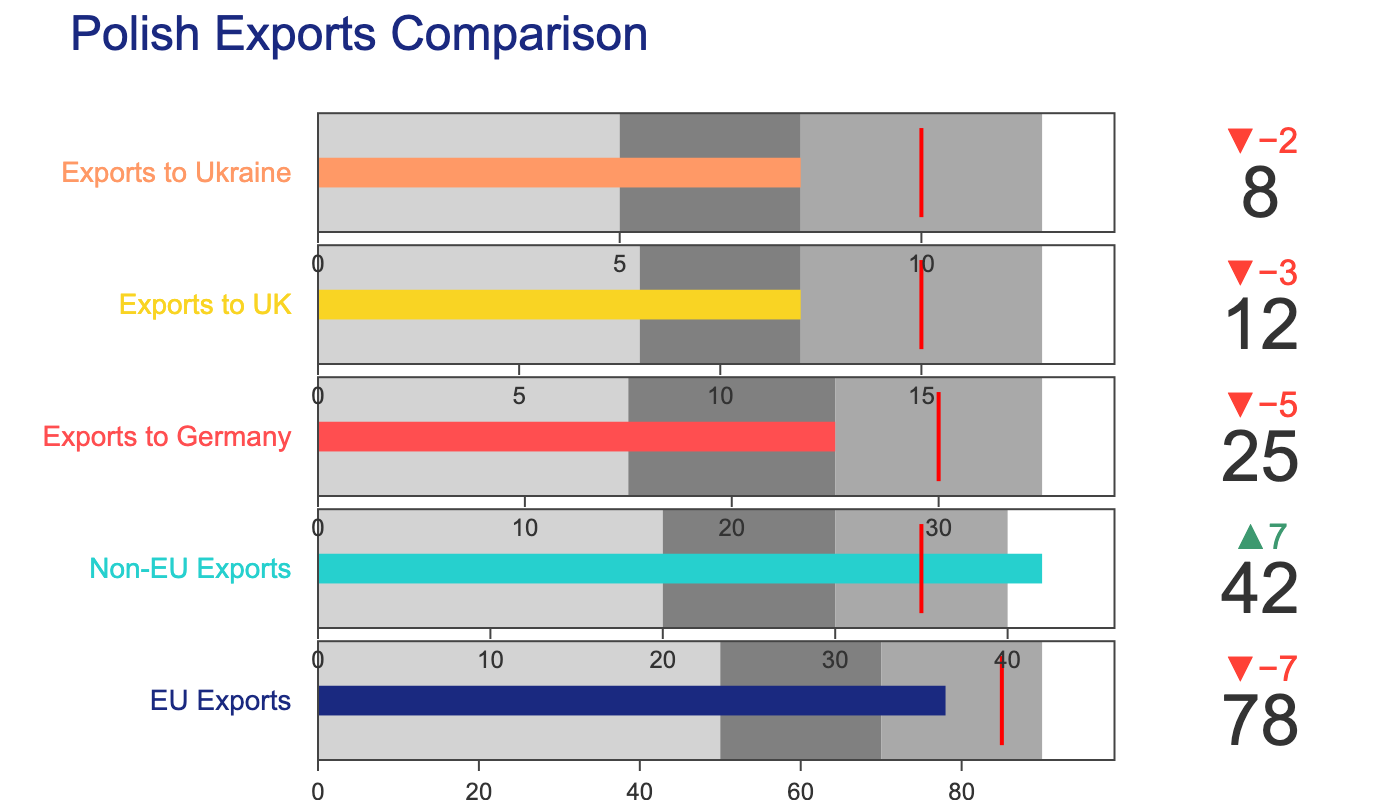What is the title of the chart? The title of the chart is typically found at the top and provides a summary of what the chart is about. In this case, the title is "Polish Exports Comparison".
Answer: Polish Exports Comparison What is the target value for EU Exports? The target value is indicated by a threshold marker in the bullet chart. For EU Exports, the target value is listed in the dataset as 85.
Answer: 85 How many categories of exports are shown in the chart? The chart lists different categories of exports in separate bullet charts. By counting the number of unique categories, we see there are 5: EU Exports, Non-EU Exports, Exports to Germany, Exports to UK, and Exports to Ukraine.
Answer: 5 Which export category has the highest actual value? To determine which category has the highest actual value, we compare the "Actual" values from each category. EU Exports has the highest actual value at 78.
Answer: EU Exports What is the actual value of Exports to UK and how does it compare to its target value? The actual value of Exports to UK can be directly read from the dataset, which is 12. Comparing it to the target value of 15 involves subtracting the actual from the target, which is 15 - 12 = 3 less than the target.
Answer: 12, 3 less than the target By how much did Non-EU Exports exceed its target value? To find how much the Non-EU Exports exceeded the target, subtract the target (35) from the actual value (42). 42 - 35 = 7.
Answer: 7 In which export categories did the actual values exceed the target values? By comparing the actual and target values in each category, we see that Non-EU Exports (42 > 35) and Exports to Ukraine (8 > 10) have actual values that exceed the target values.
Answer: Non-EU Exports, Exports to Ukraine What color appears in the bar for Exports to Germany? The color for each category's bar can be found by referring to the chart's colors. Exports to Germany uses the third color in the list, which is a specific shade used in the bullet chart for this category.
Answer: Third color in the list (hex: #ff4e50) What is the range interval for values between 50 and 70 in the EU Exports bullet chart? The range for the EU Exports bullet chart can be divided into intervals based on the dataset. The interval between 50 and 70 represents the first range (Range1) and second range (Range2).
Answer: Range1 and Range2 Which category is closest to its target value, and by how much does it miss or exceed the target? We compare the actual and target values to see which category has the smallest difference. Exports to Ukraine has the smallest difference with actual value 8 and target 10, missing the target by 2.
Answer: Exports to Ukraine, 2 